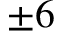Convert formula to latex. <formula><loc_0><loc_0><loc_500><loc_500>\pm 6</formula> 